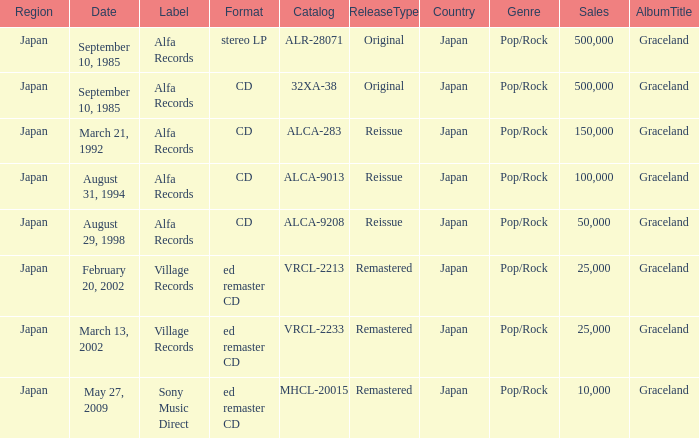Which Label was cataloged as alca-9013? Alfa Records. 